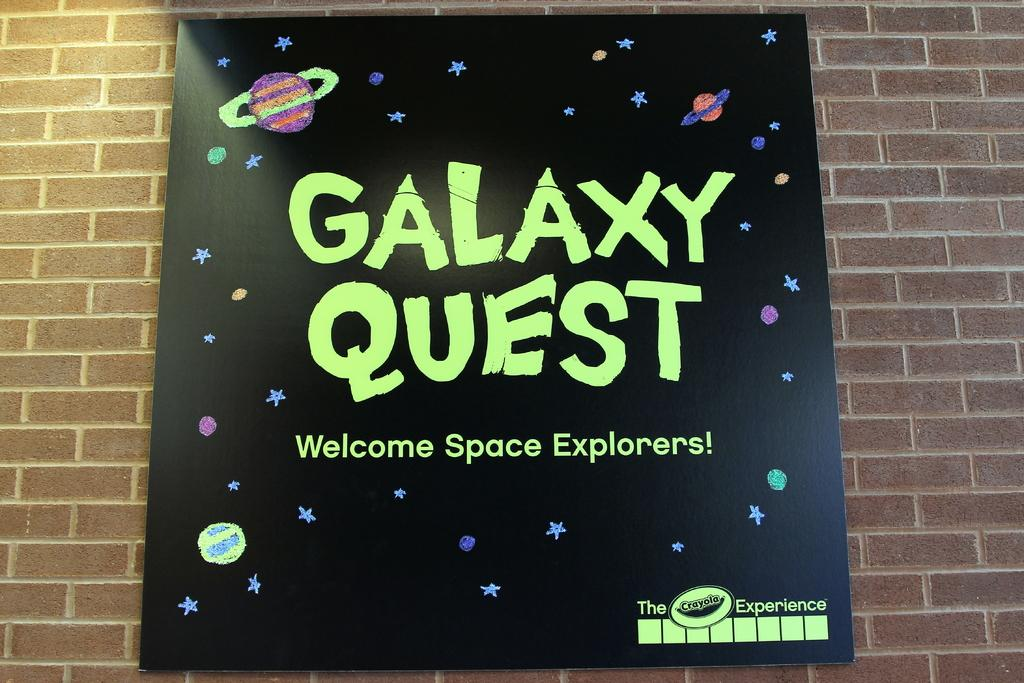Provide a one-sentence caption for the provided image. A sign advertising Galaxy Quest in black with green letters. 